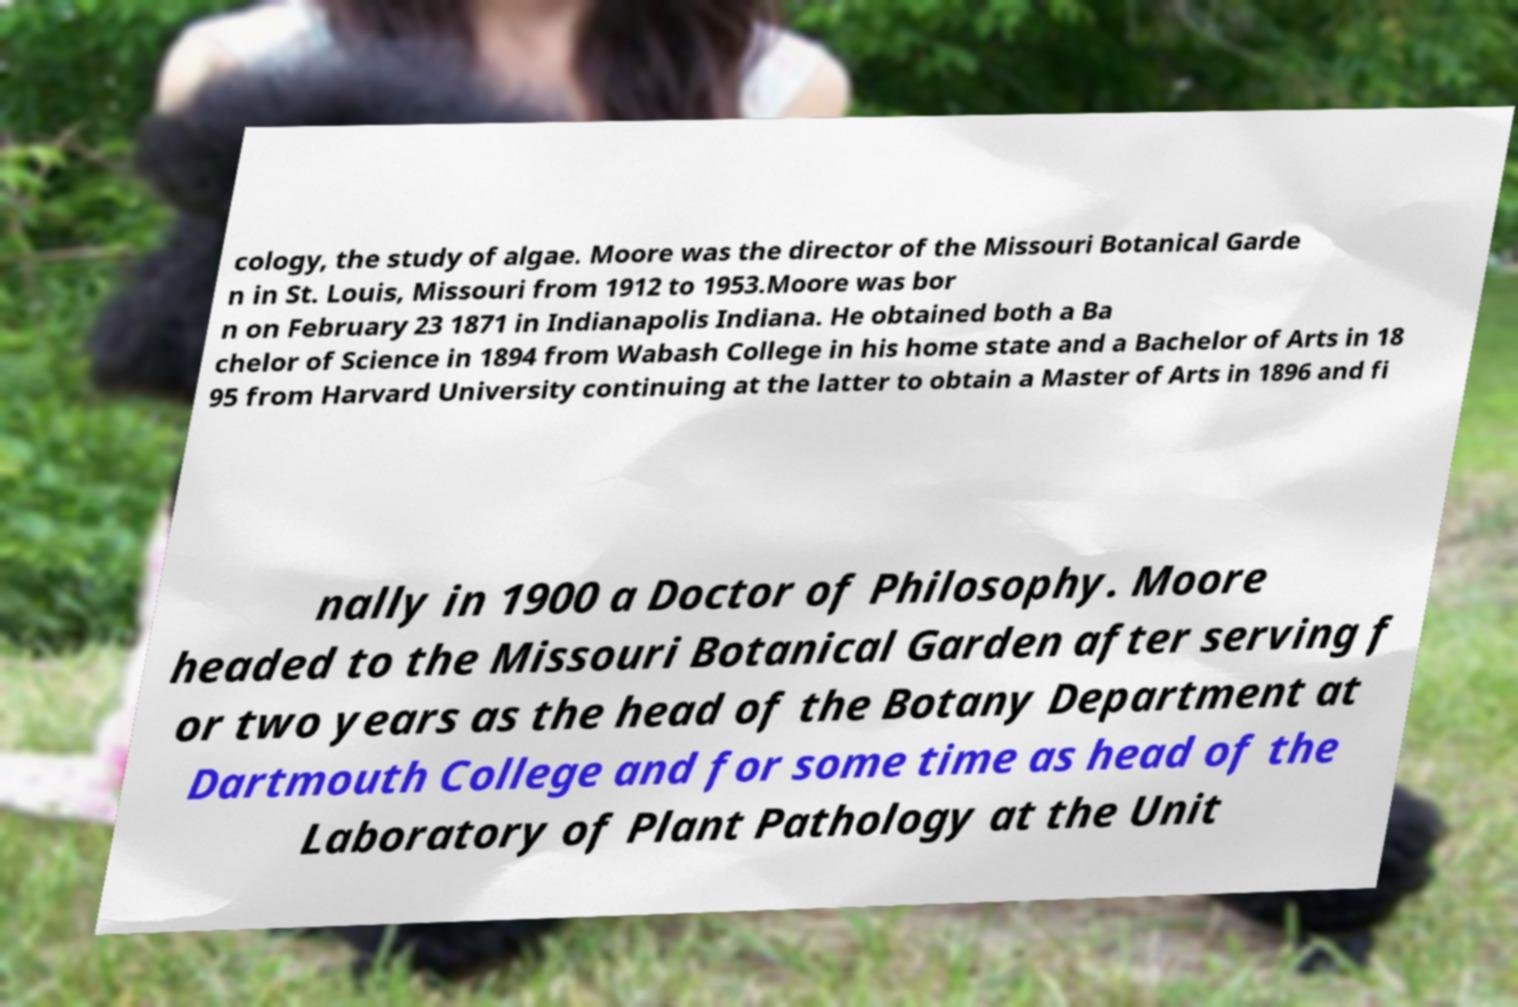Can you read and provide the text displayed in the image?This photo seems to have some interesting text. Can you extract and type it out for me? cology, the study of algae. Moore was the director of the Missouri Botanical Garde n in St. Louis, Missouri from 1912 to 1953.Moore was bor n on February 23 1871 in Indianapolis Indiana. He obtained both a Ba chelor of Science in 1894 from Wabash College in his home state and a Bachelor of Arts in 18 95 from Harvard University continuing at the latter to obtain a Master of Arts in 1896 and fi nally in 1900 a Doctor of Philosophy. Moore headed to the Missouri Botanical Garden after serving f or two years as the head of the Botany Department at Dartmouth College and for some time as head of the Laboratory of Plant Pathology at the Unit 